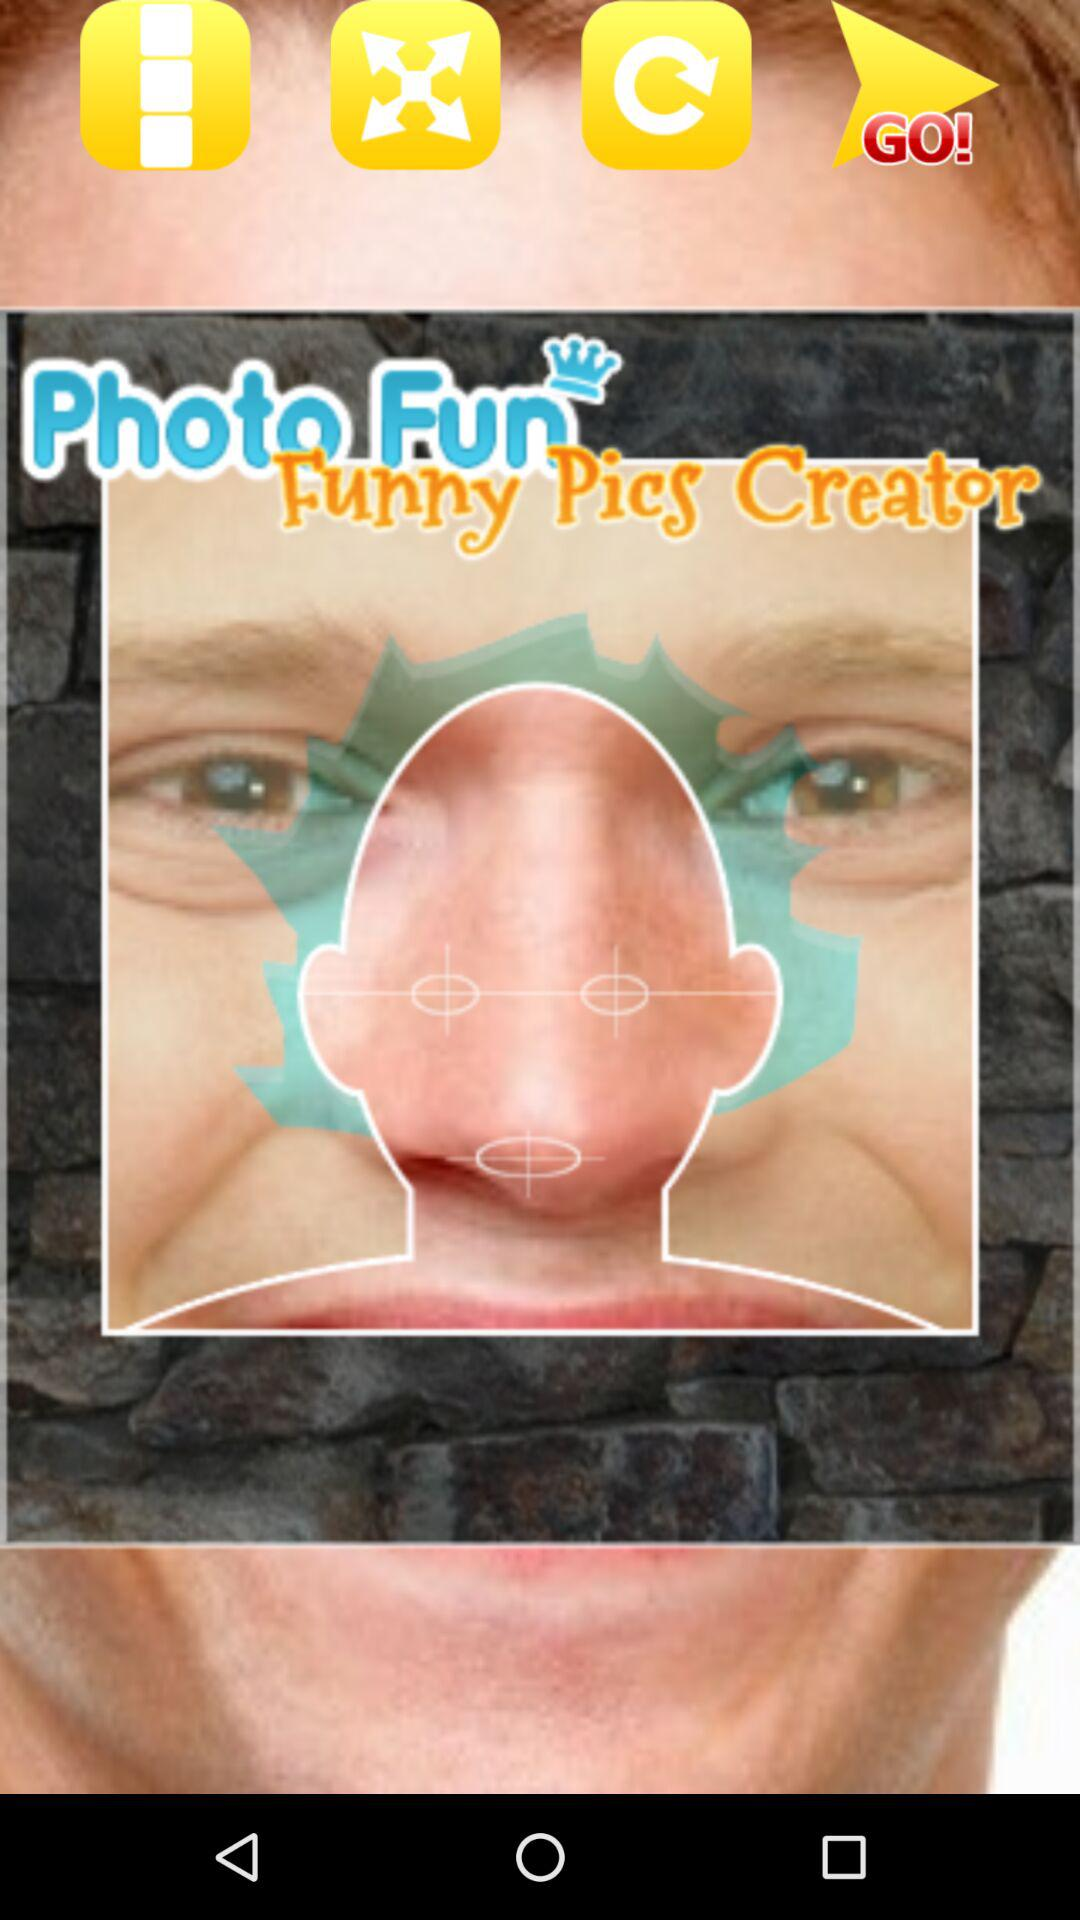How many pictures are there?
When the provided information is insufficient, respond with <no answer>. <no answer> 